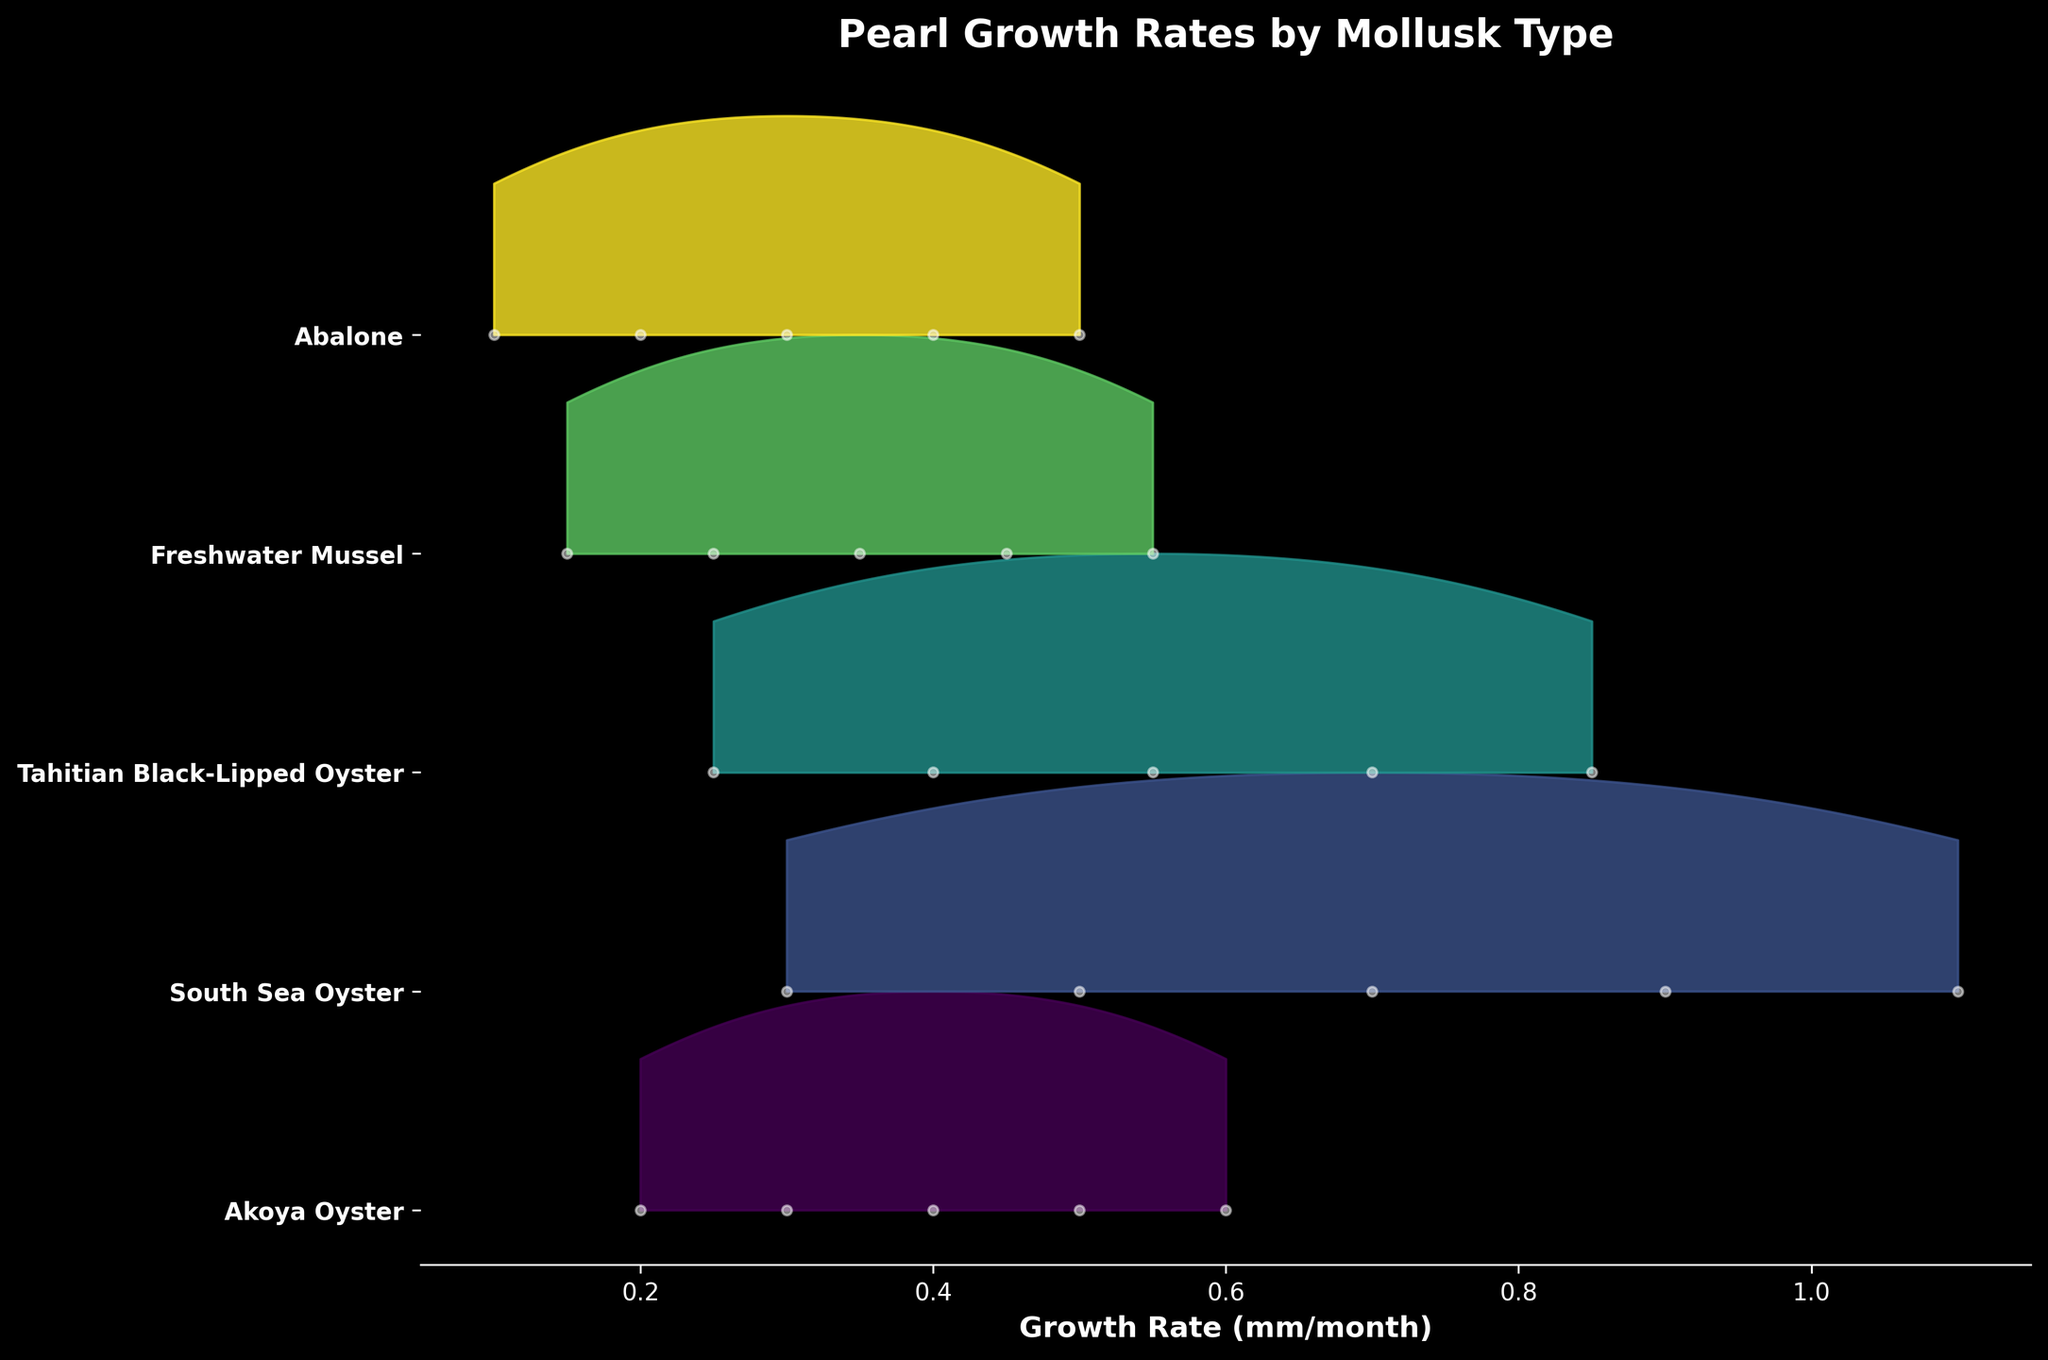Which mollusk type has the highest growth rate? Look at the plot and identify which mollusk type reaches the highest value on the x-axis representing 'Growth Rate (mm/month)'. The South Sea Oyster has the highest growth rate, peaking at approximately 1.1 mm/month.
Answer: South Sea Oyster What is the title of the plot? The title is usually displayed at the top of the plot. Here, it shows the title in bold.
Answer: Pearl Growth Rates by Mollusk Type Which mollusk type has the lowest initial growth rate? Check the starting point for each mollusk type on the x-axis. Abalone starts at 0.1 mm/month, which is the lowest initial growth rate.
Answer: Abalone How many types of mollusks are represented in the plot? Count the number of distinct mollusk types listed on the y-axis. There are five types: Akoya Oyster, South Sea Oyster, Tahitian Black-Lipped Oyster, Freshwater Mussel, and Abalone.
Answer: 5 Which mollusk type shows the most consistent growth rate over the months? Look at the density of points for each mollusk type and check the consistency. Abalone shows steady growth with consistent intervals, rising from 0.1 to 0.5 mm/month over five months.
Answer: Abalone How does the growth rate of Tahitian Black-Lipped Oyster compare to South Sea Oyster over time? Compare their KDE curves, points, and ranges on the x-axis. Tahitian Black-Lipped Oyster's growth rate is generally lower than that of South Sea Oyster at all observed months, peaking at 0.85 mm/month versus South Sea's 1.1 mm/month.
Answer: Tahitian Black-Lipped Oyster is lower What is the growth rate range for Freshwater Mussel? Observe the x-axis range that Freshwater Mussel spans. It starts at 0.15 mm/month and ends at 0.55 mm/month.
Answer: 0.15 to 0.55 mm/month Which mollusk type shows the steepest increase in growth rate? Identify the mollusk type with the steepest incline. South Sea Oyster shows the sharpest rise from 0.3 to 1.1 mm/month, indicating the steepest increase in growth rate.
Answer: South Sea Oyster How do the growth rates of Akoya Oyster and Freshwater Mussel compare in the 4th month? Compare their growth rates from the 4th month on the x-axis. Akoya Oyster has a growth rate of 0.5 mm/month, while Freshwater Mussel has 0.45 mm/month in the same month.
Answer: Akoya Oyster is higher 